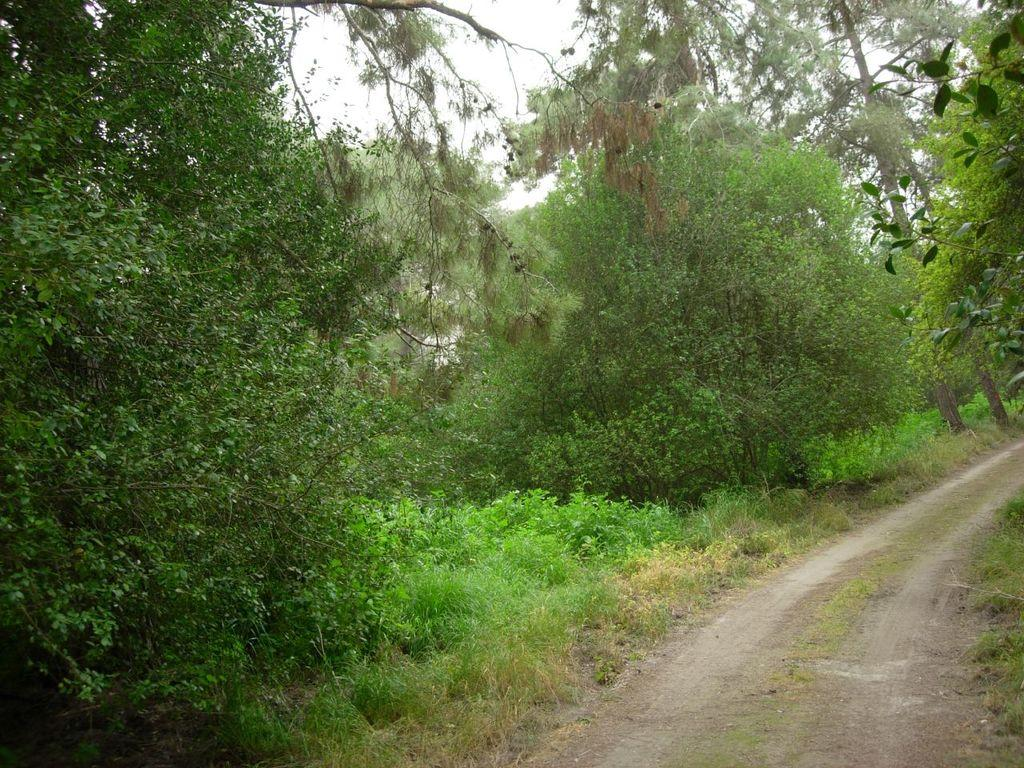What is the main feature of the image? There is a path in the image. What can be seen on both sides of the path? Grass is visible on both sides of the path. What is visible in the background of the image? There are plants and trees in the background of the image. How many fangs can be seen on the dog in the image? There is no dog present in the image, and therefore no fangs can be seen. What type of giants are visible in the background of the image? There are no giants present in the image; it features plants and trees in the background. 